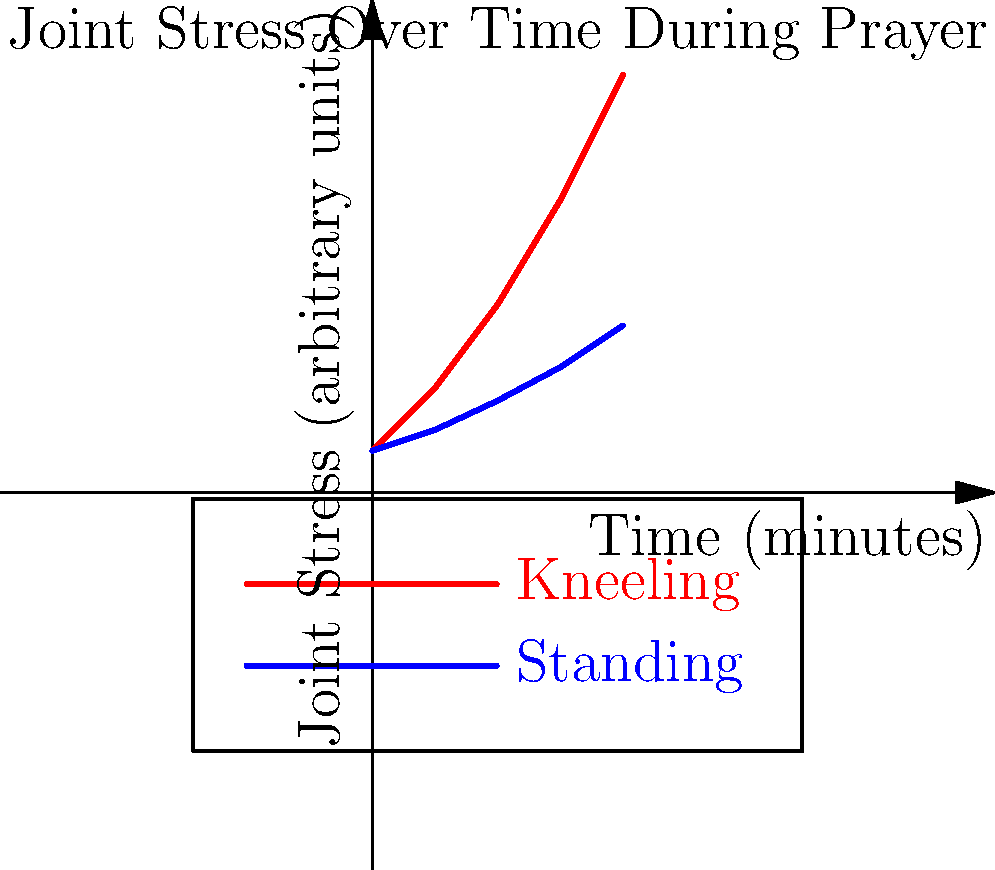Based on the graph depicting joint stress over time during prayer, what theological implications might you draw regarding the biomechanical differences between kneeling and standing postures in prolonged worship practices? How might this inform our understanding of various prayer traditions in biblical texts? To analyze this graph from a biblical scholar's perspective, we should consider the following steps:

1. Observe the data: The graph shows joint stress increasing over time for both kneeling and standing postures during prayer.

2. Compare the trends: Kneeling shows a steeper increase in joint stress compared to standing.

3. Consider the time frame: The graph covers a 60-minute period, which could represent an extended prayer or meditation session.

4. Relate to biblical practices: Many biblical texts mention both kneeling (e.g., 1 Kings 8:54, Ephesians 3:14) and standing (e.g., Mark 11:25, Luke 18:11) for prayer.

5. Apply form-critical analysis: Consider how the physical form of prayer might have influenced the development of prayer traditions in different biblical texts.

6. Redaction-critical perspective: Examine how later editors might have emphasized certain prayer postures based on their understanding of physical comfort or spiritual significance.

7. Theological implications:
   a. The higher stress in kneeling might be seen as a form of physical sacrifice or humility before God.
   b. The lower stress in standing could be interpreted as promoting endurance in prayer.
   c. The varying stress levels might explain the diversity of prayer postures in different biblical traditions.

8. Pastoral considerations: The graph might inform how we interpret and apply biblical prayer practices in contemporary worship settings, especially for those with physical limitations.

9. Textual analysis: This data might provide new insights into why certain biblical authors chose to emphasize particular prayer postures in their writings.

10. Liturgical development: The biomechanical differences could help explain the evolution of liturgical practices in early Christian and Jewish traditions as reflected in biblical and extra-biblical texts.
Answer: The biomechanical differences suggest that kneeling represents a more physically demanding form of prayer, potentially influencing the development and interpretation of prayer traditions in biblical texts. 